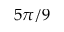<formula> <loc_0><loc_0><loc_500><loc_500>5 \pi / 9</formula> 